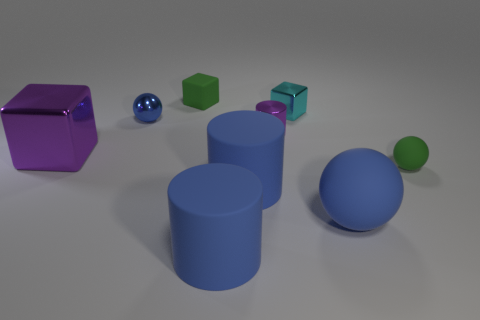Does the scene imply these objects could be part of a teaching tool or game, and why? These objects could indeed be part of a teaching tool or an educational game, given their distinct and vibrant colors, as well as their representative geometric shapes. They seem ideal for helping learners understand spatial concepts and the properties of different geometries, such as volume and surface area. 